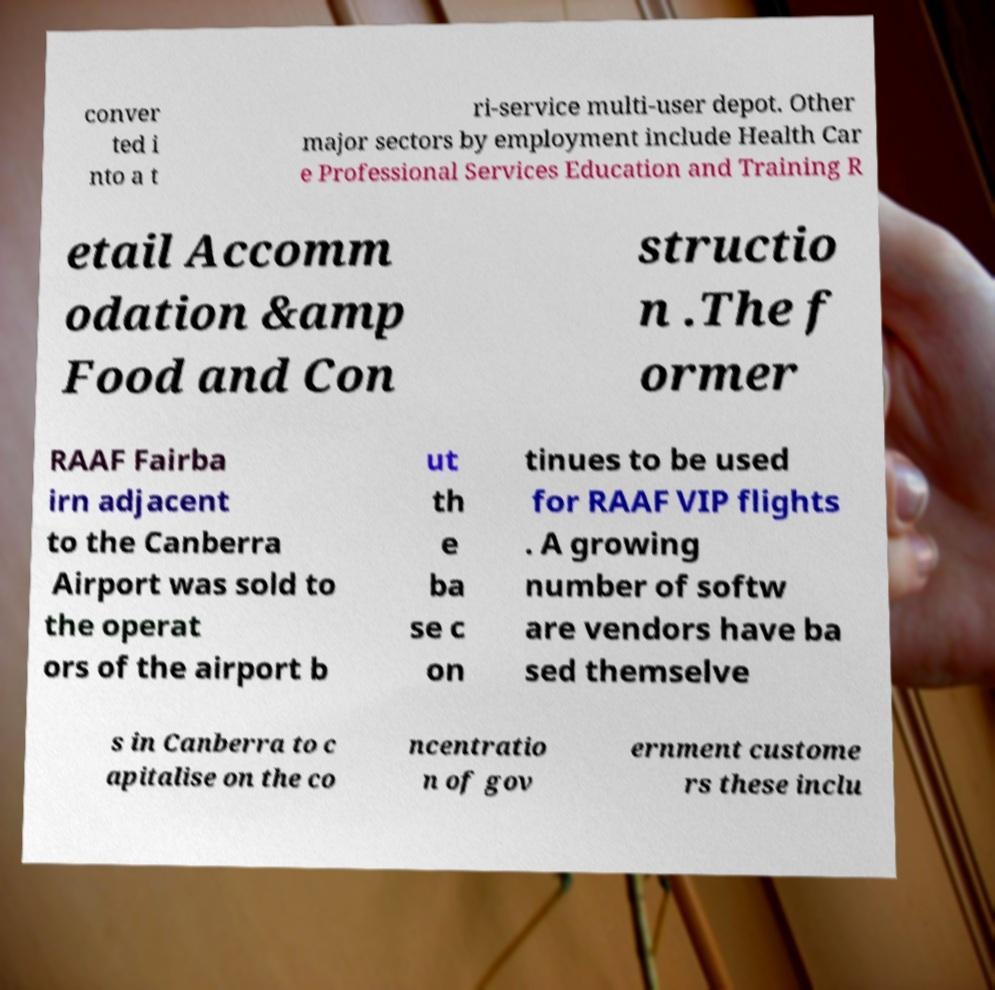Can you read and provide the text displayed in the image?This photo seems to have some interesting text. Can you extract and type it out for me? conver ted i nto a t ri-service multi-user depot. Other major sectors by employment include Health Car e Professional Services Education and Training R etail Accomm odation &amp Food and Con structio n .The f ormer RAAF Fairba irn adjacent to the Canberra Airport was sold to the operat ors of the airport b ut th e ba se c on tinues to be used for RAAF VIP flights . A growing number of softw are vendors have ba sed themselve s in Canberra to c apitalise on the co ncentratio n of gov ernment custome rs these inclu 